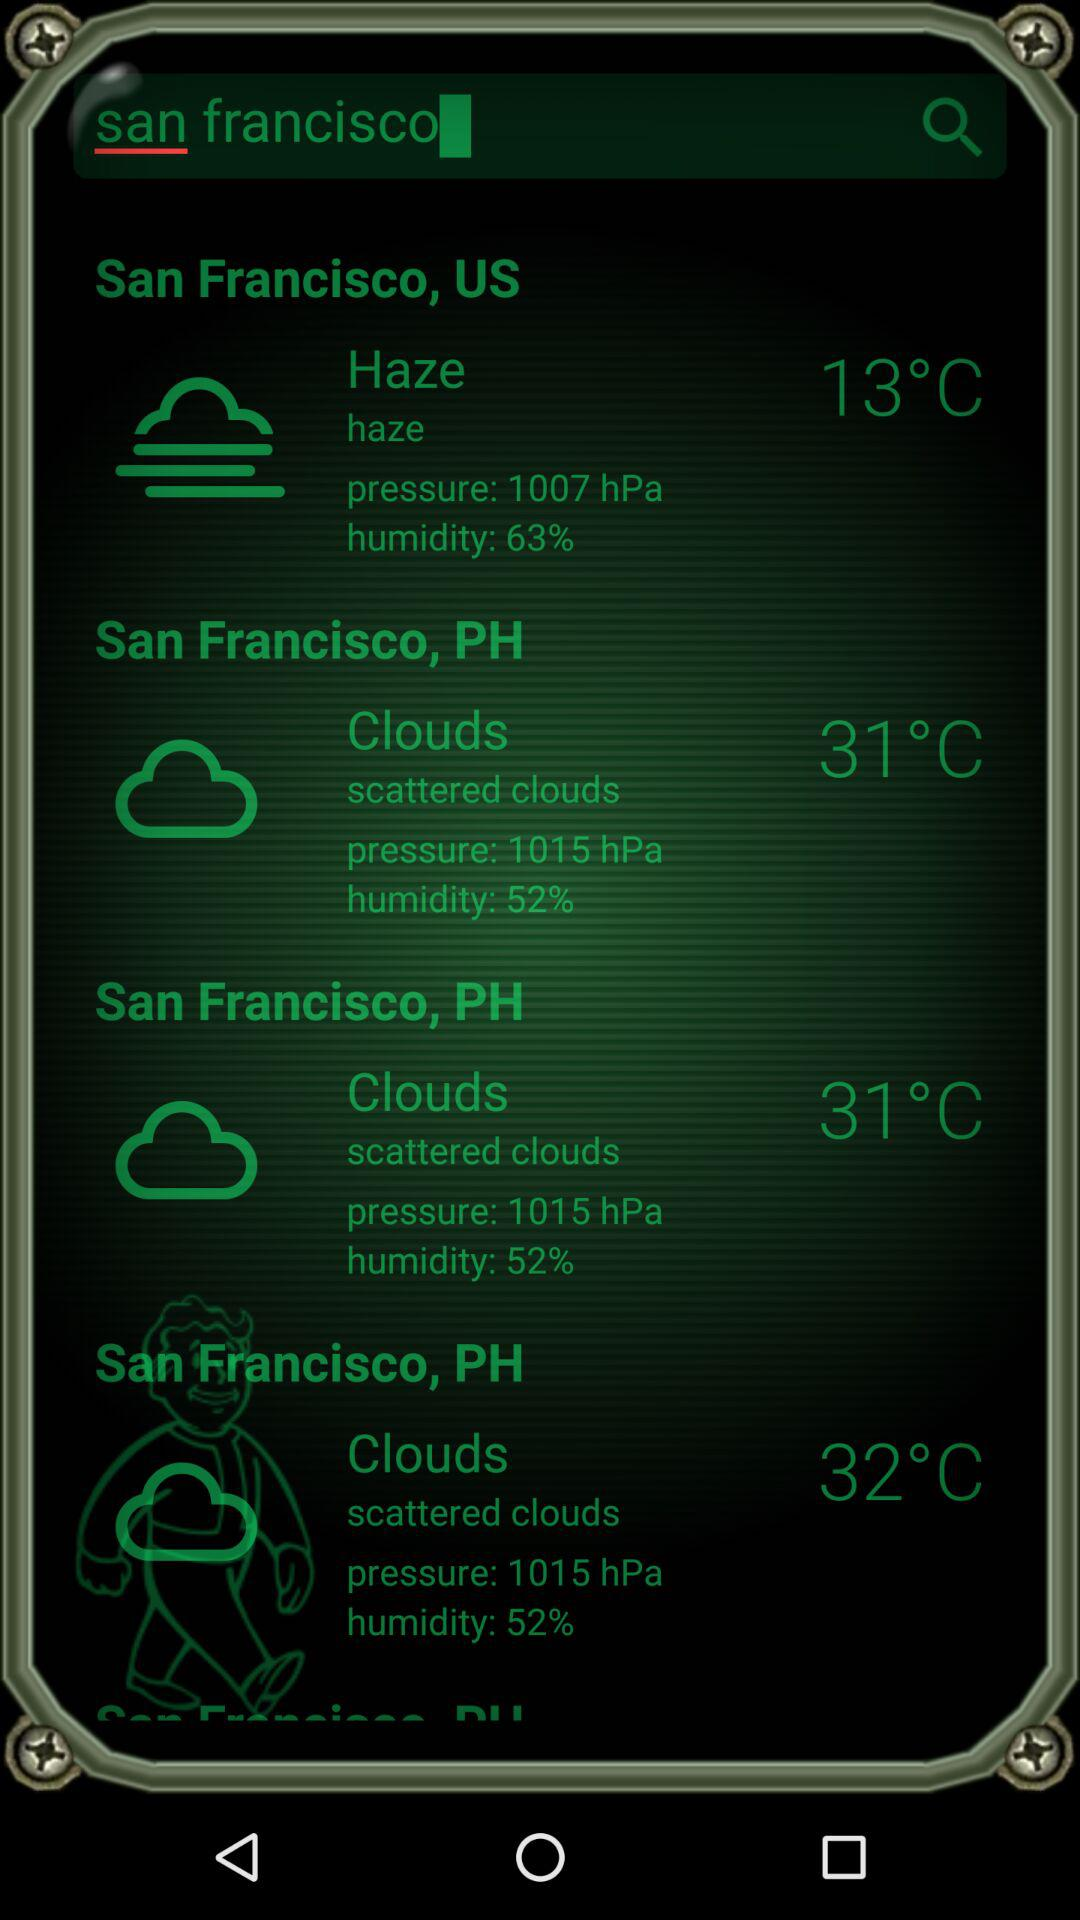What is the humidity of haze? The humidity is 63%. 